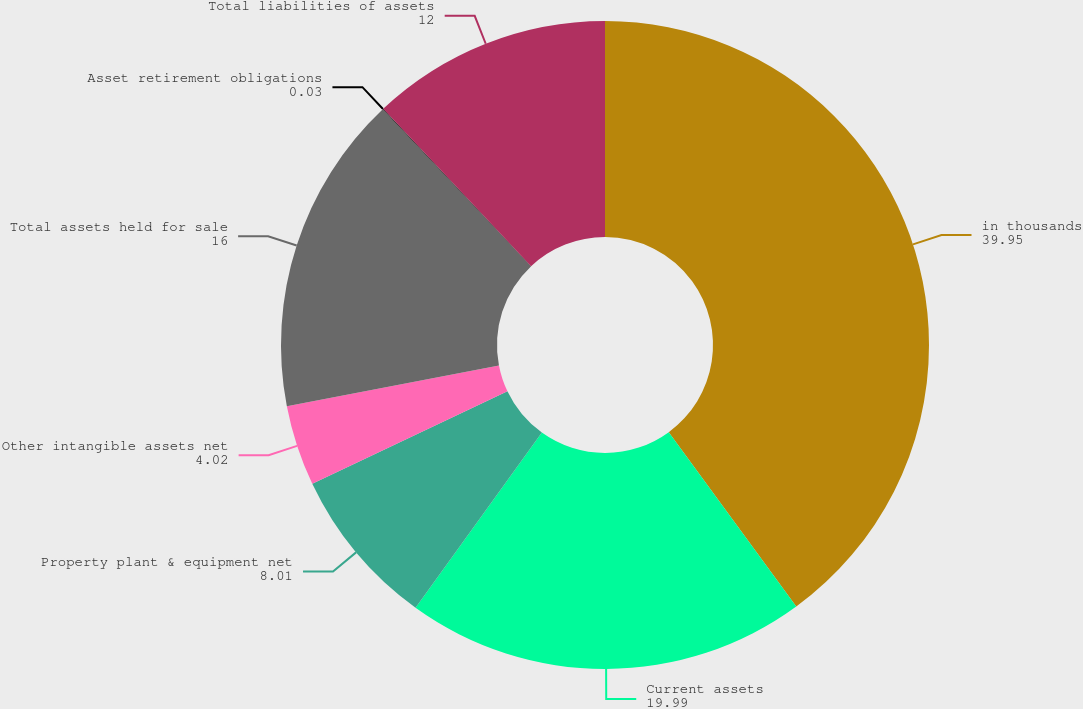Convert chart. <chart><loc_0><loc_0><loc_500><loc_500><pie_chart><fcel>in thousands<fcel>Current assets<fcel>Property plant & equipment net<fcel>Other intangible assets net<fcel>Total assets held for sale<fcel>Asset retirement obligations<fcel>Total liabilities of assets<nl><fcel>39.95%<fcel>19.99%<fcel>8.01%<fcel>4.02%<fcel>16.0%<fcel>0.03%<fcel>12.0%<nl></chart> 